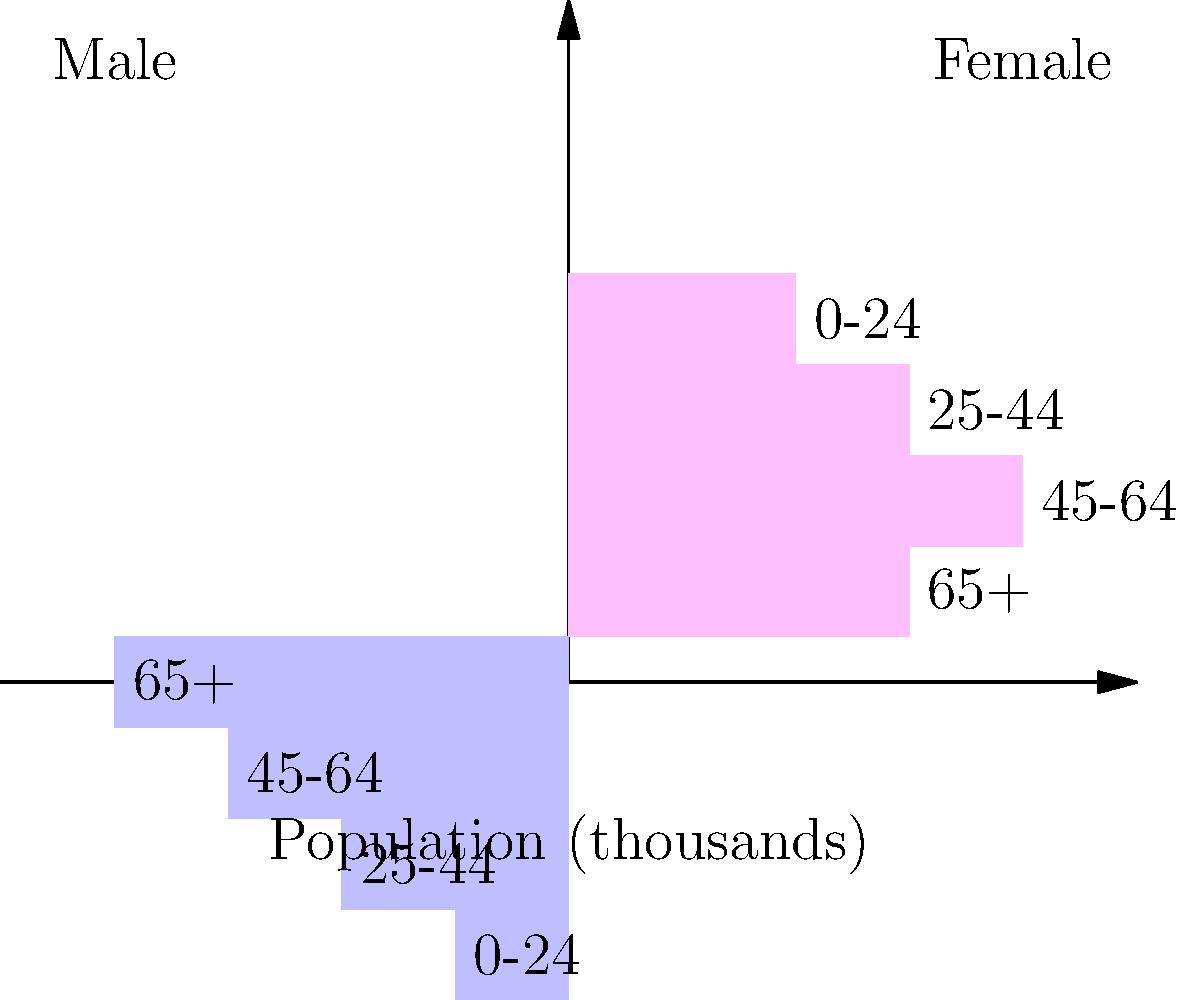As a small business owner, you're analyzing customer demographics to optimize your marketing strategy. The population pyramid above represents the age and gender distribution of your local market. What percentage of the total population is represented by females aged 45-64? To solve this problem, we need to follow these steps:

1. Calculate the total population:
   Male: 4 + 3 + 2 + 1 = 10
   Female: 3 + 4 + 3 + 2 = 12
   Total: 10 + 12 = 22 thousand

2. Identify the number of females aged 45-64:
   From the chart, we can see that females aged 45-64 represent 4 thousand people.

3. Calculate the percentage:
   Percentage = (Number in group / Total population) × 100
   $$ \text{Percentage} = \frac{4}{22} \times 100 \approx 18.18\% $$

4. Round to the nearest whole number:
   18.18% rounds to 18%

Therefore, females aged 45-64 represent approximately 18% of the total population.
Answer: 18% 